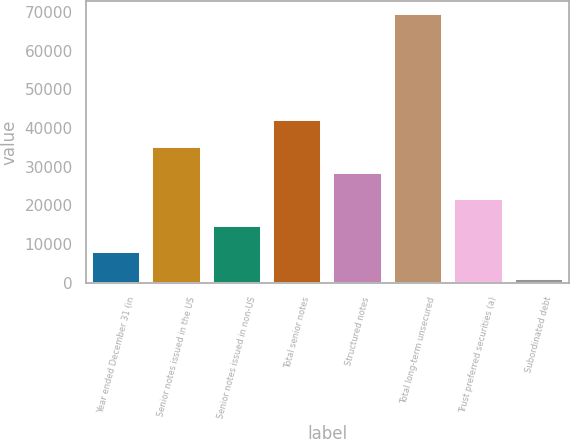Convert chart to OTSL. <chart><loc_0><loc_0><loc_500><loc_500><bar_chart><fcel>Year ended December 31 (in<fcel>Senior notes issued in the US<fcel>Senior notes issued in non-US<fcel>Total senior notes<fcel>Structured notes<fcel>Total long-term unsecured<fcel>Trust preferred securities (a)<fcel>Subordinated debt<nl><fcel>7881.4<fcel>35227<fcel>14717.8<fcel>42063.4<fcel>28390.6<fcel>69409<fcel>21554.2<fcel>1045<nl></chart> 